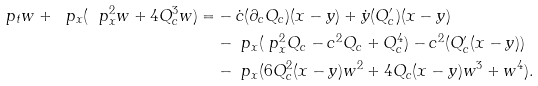<formula> <loc_0><loc_0><loc_500><loc_500>\ p _ { t } w + \ p _ { x } ( \ p _ { x } ^ { 2 } w + 4 Q _ { c } ^ { 3 } w ) = & - \dot { c } ( \partial _ { c } Q _ { c } ) ( x - y ) + \dot { y } ( Q _ { c } ^ { \prime } ) ( x - y ) \\ & - \ p _ { x } ( \ p _ { x } ^ { 2 } Q _ { c } - c ^ { 2 } Q _ { c } + Q _ { c } ^ { 4 } ) - c ^ { 2 } ( Q _ { c } ^ { \prime } ( x - y ) ) \\ & - \ p _ { x } ( 6 Q _ { c } ^ { 2 } ( x - y ) w ^ { 2 } + 4 Q _ { c } ( x - y ) w ^ { 3 } + w ^ { 4 } ) .</formula> 